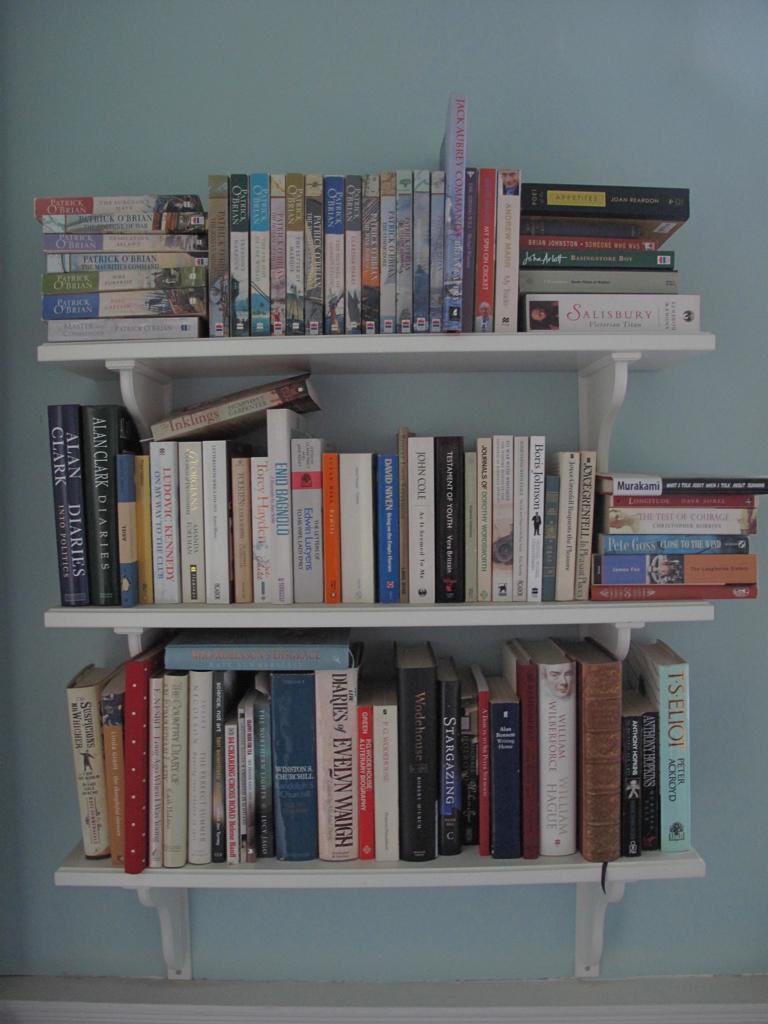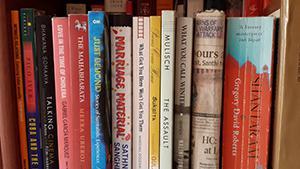The first image is the image on the left, the second image is the image on the right. Given the left and right images, does the statement "There are at least 13 books that are red, blue or white sitting on a single unseen shelve." hold true? Answer yes or no. Yes. The first image is the image on the left, the second image is the image on the right. Considering the images on both sides, is "One image shows the spines of books lined upright in a row, and the other image shows books stacked mostly upright on shelves, with some books stacked on their sides." valid? Answer yes or no. Yes. 